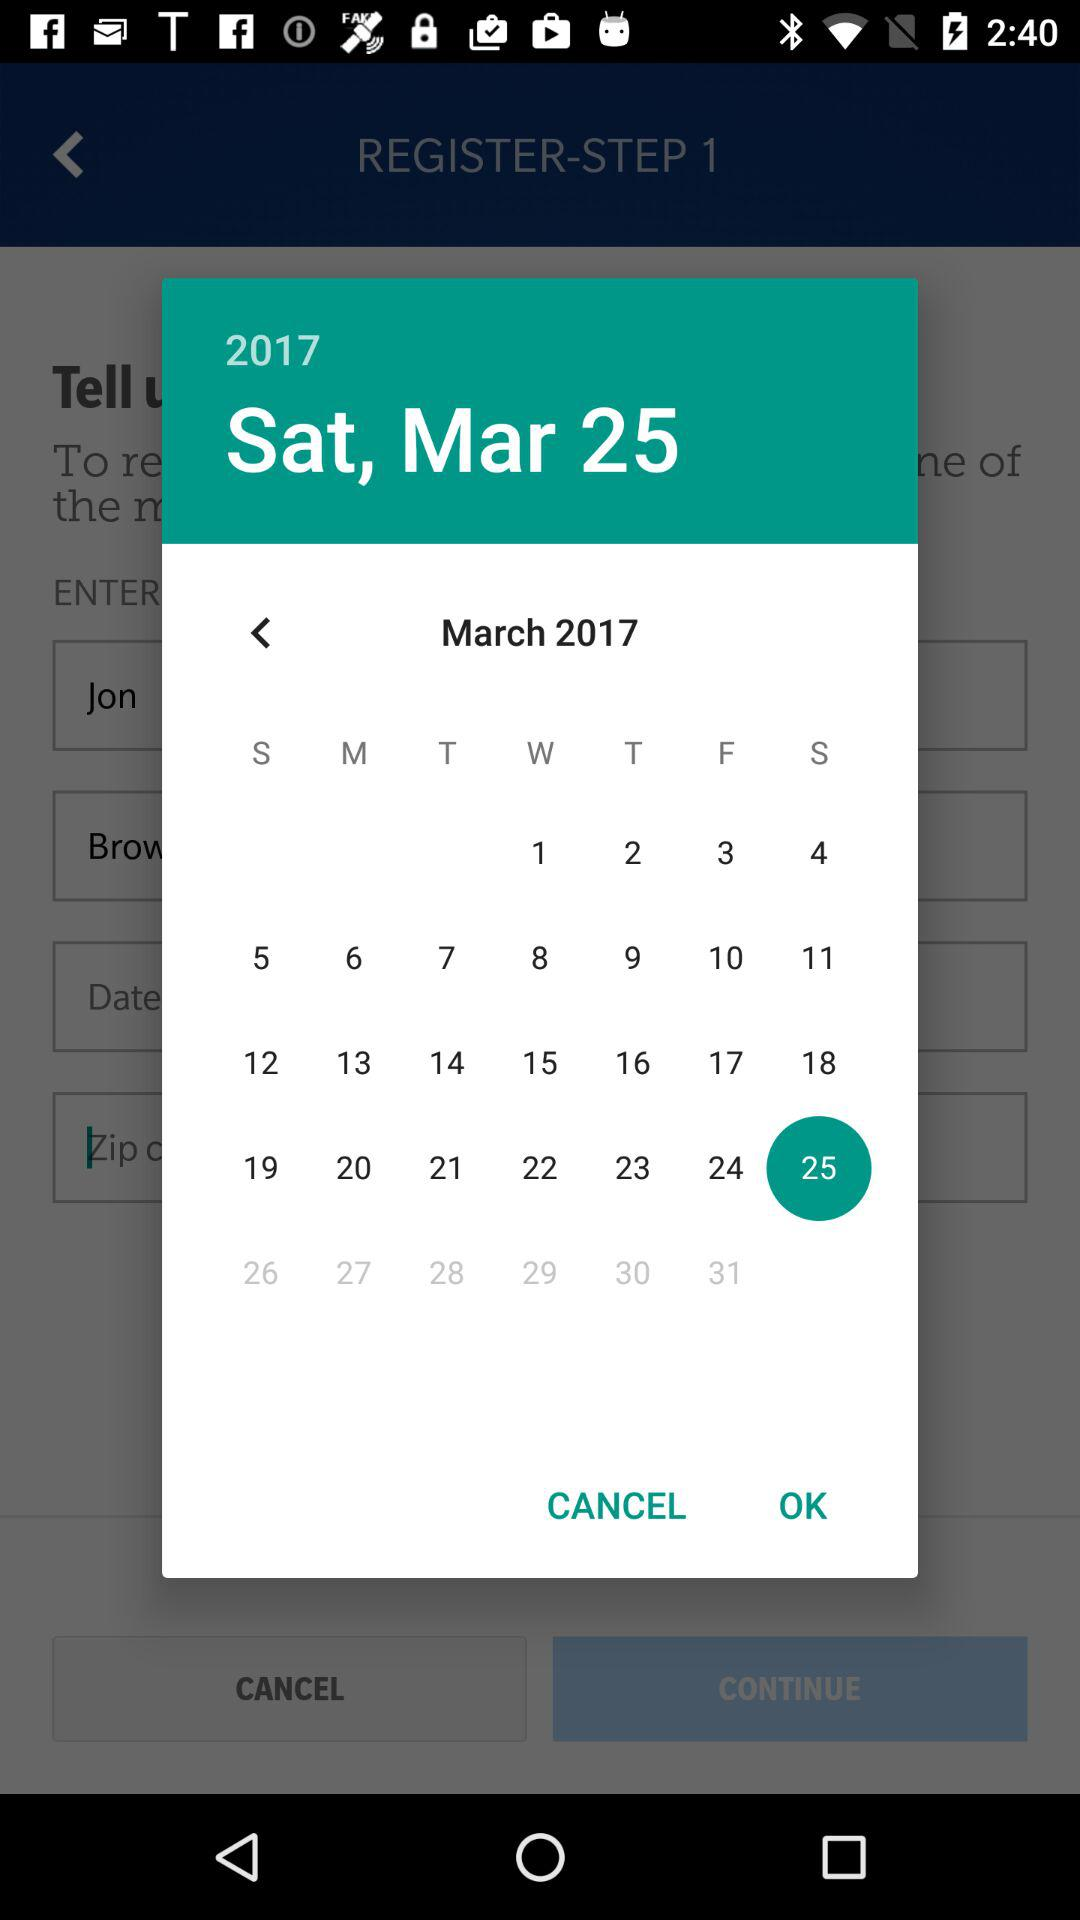What day falls on March 25, 2017? The day is "Saturday". 